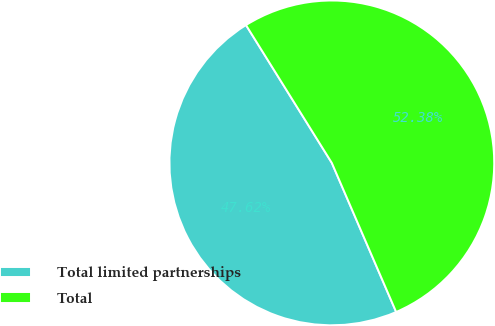<chart> <loc_0><loc_0><loc_500><loc_500><pie_chart><fcel>Total limited partnerships<fcel>Total<nl><fcel>47.62%<fcel>52.38%<nl></chart> 